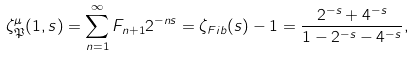<formula> <loc_0><loc_0><loc_500><loc_500>\zeta ^ { \mu } _ { \mathfrak { P } } ( 1 , s ) = \sum _ { n = 1 } ^ { \infty } F _ { n + 1 } 2 ^ { - n s } = \zeta _ { F i b } ( s ) - 1 = \frac { 2 ^ { - s } + 4 ^ { - s } } { 1 - 2 ^ { - s } - 4 ^ { - s } } ,</formula> 